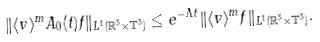Convert formula to latex. <formula><loc_0><loc_0><loc_500><loc_500>\| \langle v \rangle ^ { m } A _ { 0 } ( t ) f \| _ { L ^ { 1 } ( \mathbb { R } ^ { 3 } \times \mathbb { T } ^ { 3 } ) } \leq e ^ { - \Lambda t } \| \langle v \rangle ^ { m } f \| _ { L ^ { 1 } ( \mathbb { R } ^ { 3 } \times \mathbb { T } ^ { 3 } ) } .</formula> 